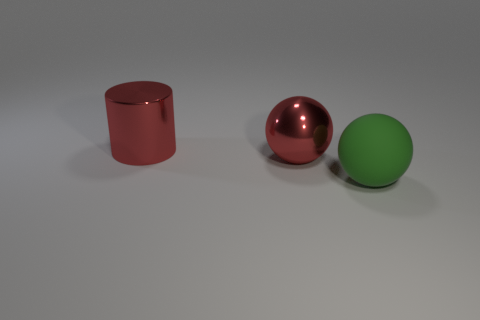Is there any other thing that is made of the same material as the large green ball?
Provide a short and direct response. No. Is the number of balls behind the green rubber ball the same as the number of red balls that are behind the large cylinder?
Keep it short and to the point. No. Are there any purple metallic spheres?
Provide a short and direct response. No. There is another thing that is the same shape as the large rubber object; what size is it?
Ensure brevity in your answer.  Large. How big is the red shiny thing that is to the right of the red cylinder?
Provide a succinct answer. Large. Are there more big red cylinders behind the green matte ball than purple metal objects?
Make the answer very short. Yes. The large green rubber thing is what shape?
Your answer should be compact. Sphere. There is a big metallic thing that is right of the metallic cylinder; is it the same color as the shiny thing behind the red ball?
Give a very brief answer. Yes. Is the ball behind the matte object made of the same material as the green sphere?
Your response must be concise. No. What shape is the thing that is both in front of the cylinder and on the left side of the big green rubber sphere?
Your response must be concise. Sphere. 